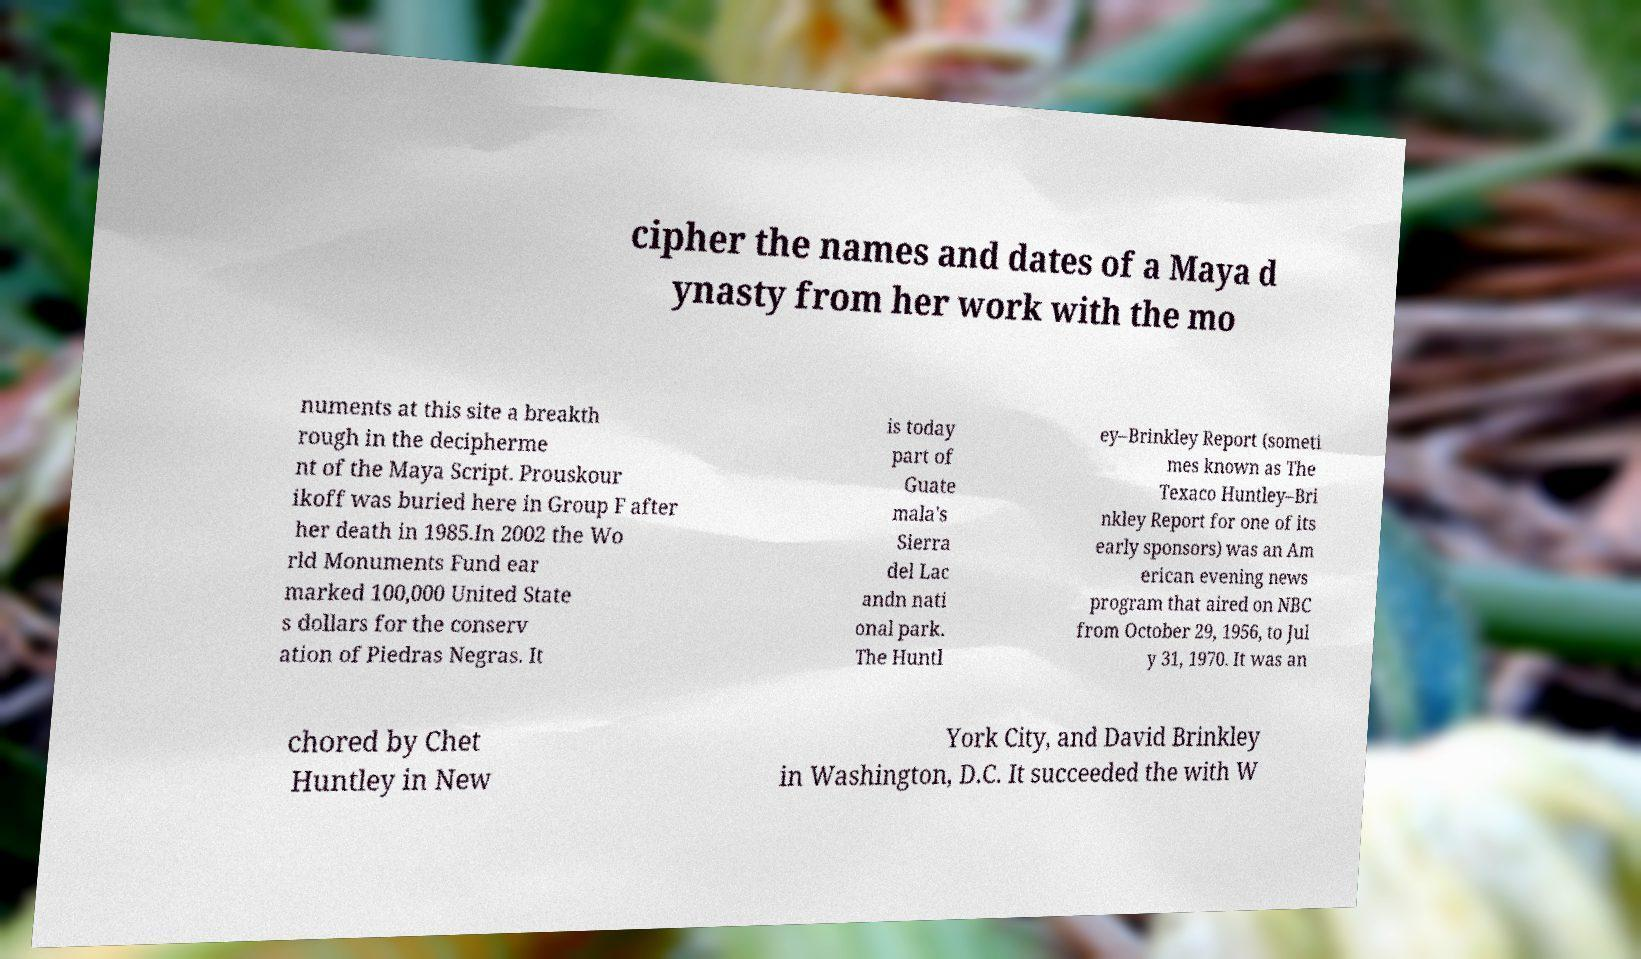Could you extract and type out the text from this image? cipher the names and dates of a Maya d ynasty from her work with the mo numents at this site a breakth rough in the decipherme nt of the Maya Script. Prouskour ikoff was buried here in Group F after her death in 1985.In 2002 the Wo rld Monuments Fund ear marked 100,000 United State s dollars for the conserv ation of Piedras Negras. It is today part of Guate mala's Sierra del Lac andn nati onal park. The Huntl ey–Brinkley Report (someti mes known as The Texaco Huntley–Bri nkley Report for one of its early sponsors) was an Am erican evening news program that aired on NBC from October 29, 1956, to Jul y 31, 1970. It was an chored by Chet Huntley in New York City, and David Brinkley in Washington, D.C. It succeeded the with W 